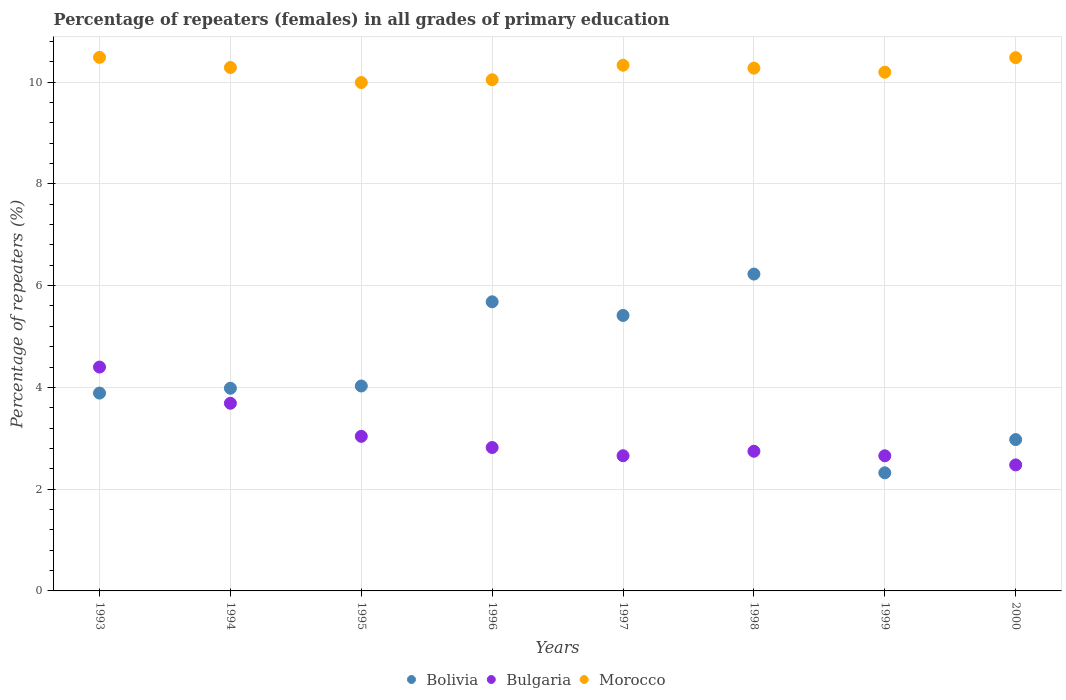How many different coloured dotlines are there?
Make the answer very short. 3. Is the number of dotlines equal to the number of legend labels?
Your answer should be compact. Yes. What is the percentage of repeaters (females) in Bolivia in 1999?
Make the answer very short. 2.32. Across all years, what is the maximum percentage of repeaters (females) in Morocco?
Offer a terse response. 10.49. Across all years, what is the minimum percentage of repeaters (females) in Bolivia?
Your response must be concise. 2.32. What is the total percentage of repeaters (females) in Bulgaria in the graph?
Your answer should be compact. 24.48. What is the difference between the percentage of repeaters (females) in Morocco in 1994 and that in 1997?
Your answer should be very brief. -0.04. What is the difference between the percentage of repeaters (females) in Bulgaria in 1993 and the percentage of repeaters (females) in Morocco in 1999?
Offer a terse response. -5.8. What is the average percentage of repeaters (females) in Morocco per year?
Your response must be concise. 10.26. In the year 1997, what is the difference between the percentage of repeaters (females) in Morocco and percentage of repeaters (females) in Bulgaria?
Your answer should be very brief. 7.67. What is the ratio of the percentage of repeaters (females) in Morocco in 1996 to that in 1998?
Your answer should be very brief. 0.98. Is the percentage of repeaters (females) in Bolivia in 1995 less than that in 1999?
Keep it short and to the point. No. Is the difference between the percentage of repeaters (females) in Morocco in 1994 and 1998 greater than the difference between the percentage of repeaters (females) in Bulgaria in 1994 and 1998?
Make the answer very short. No. What is the difference between the highest and the second highest percentage of repeaters (females) in Morocco?
Keep it short and to the point. 0.01. What is the difference between the highest and the lowest percentage of repeaters (females) in Bulgaria?
Your answer should be compact. 1.92. Is the sum of the percentage of repeaters (females) in Bolivia in 1996 and 1997 greater than the maximum percentage of repeaters (females) in Bulgaria across all years?
Provide a short and direct response. Yes. Is it the case that in every year, the sum of the percentage of repeaters (females) in Morocco and percentage of repeaters (females) in Bolivia  is greater than the percentage of repeaters (females) in Bulgaria?
Ensure brevity in your answer.  Yes. Does the percentage of repeaters (females) in Bolivia monotonically increase over the years?
Give a very brief answer. No. Is the percentage of repeaters (females) in Bulgaria strictly greater than the percentage of repeaters (females) in Bolivia over the years?
Provide a succinct answer. No. How many dotlines are there?
Keep it short and to the point. 3. How many years are there in the graph?
Offer a terse response. 8. Are the values on the major ticks of Y-axis written in scientific E-notation?
Ensure brevity in your answer.  No. Does the graph contain any zero values?
Provide a short and direct response. No. How many legend labels are there?
Make the answer very short. 3. How are the legend labels stacked?
Offer a very short reply. Horizontal. What is the title of the graph?
Your answer should be very brief. Percentage of repeaters (females) in all grades of primary education. Does "Central African Republic" appear as one of the legend labels in the graph?
Offer a terse response. No. What is the label or title of the Y-axis?
Make the answer very short. Percentage of repeaters (%). What is the Percentage of repeaters (%) in Bolivia in 1993?
Your response must be concise. 3.89. What is the Percentage of repeaters (%) of Bulgaria in 1993?
Provide a short and direct response. 4.4. What is the Percentage of repeaters (%) in Morocco in 1993?
Provide a short and direct response. 10.49. What is the Percentage of repeaters (%) of Bolivia in 1994?
Provide a succinct answer. 3.98. What is the Percentage of repeaters (%) in Bulgaria in 1994?
Give a very brief answer. 3.69. What is the Percentage of repeaters (%) in Morocco in 1994?
Offer a very short reply. 10.29. What is the Percentage of repeaters (%) of Bolivia in 1995?
Your response must be concise. 4.03. What is the Percentage of repeaters (%) in Bulgaria in 1995?
Your answer should be very brief. 3.04. What is the Percentage of repeaters (%) of Morocco in 1995?
Your answer should be very brief. 9.99. What is the Percentage of repeaters (%) of Bolivia in 1996?
Provide a short and direct response. 5.68. What is the Percentage of repeaters (%) of Bulgaria in 1996?
Offer a terse response. 2.82. What is the Percentage of repeaters (%) in Morocco in 1996?
Provide a succinct answer. 10.05. What is the Percentage of repeaters (%) in Bolivia in 1997?
Ensure brevity in your answer.  5.41. What is the Percentage of repeaters (%) in Bulgaria in 1997?
Your answer should be compact. 2.66. What is the Percentage of repeaters (%) of Morocco in 1997?
Give a very brief answer. 10.33. What is the Percentage of repeaters (%) of Bolivia in 1998?
Make the answer very short. 6.23. What is the Percentage of repeaters (%) of Bulgaria in 1998?
Your answer should be compact. 2.74. What is the Percentage of repeaters (%) of Morocco in 1998?
Your answer should be very brief. 10.27. What is the Percentage of repeaters (%) in Bolivia in 1999?
Keep it short and to the point. 2.32. What is the Percentage of repeaters (%) in Bulgaria in 1999?
Ensure brevity in your answer.  2.66. What is the Percentage of repeaters (%) in Morocco in 1999?
Keep it short and to the point. 10.2. What is the Percentage of repeaters (%) of Bolivia in 2000?
Your answer should be compact. 2.97. What is the Percentage of repeaters (%) of Bulgaria in 2000?
Give a very brief answer. 2.48. What is the Percentage of repeaters (%) in Morocco in 2000?
Offer a very short reply. 10.48. Across all years, what is the maximum Percentage of repeaters (%) of Bolivia?
Your answer should be compact. 6.23. Across all years, what is the maximum Percentage of repeaters (%) of Bulgaria?
Offer a very short reply. 4.4. Across all years, what is the maximum Percentage of repeaters (%) of Morocco?
Offer a very short reply. 10.49. Across all years, what is the minimum Percentage of repeaters (%) of Bolivia?
Give a very brief answer. 2.32. Across all years, what is the minimum Percentage of repeaters (%) of Bulgaria?
Make the answer very short. 2.48. Across all years, what is the minimum Percentage of repeaters (%) in Morocco?
Ensure brevity in your answer.  9.99. What is the total Percentage of repeaters (%) in Bolivia in the graph?
Offer a terse response. 34.52. What is the total Percentage of repeaters (%) in Bulgaria in the graph?
Your answer should be compact. 24.48. What is the total Percentage of repeaters (%) of Morocco in the graph?
Your answer should be compact. 82.1. What is the difference between the Percentage of repeaters (%) of Bolivia in 1993 and that in 1994?
Give a very brief answer. -0.1. What is the difference between the Percentage of repeaters (%) of Bulgaria in 1993 and that in 1994?
Provide a short and direct response. 0.71. What is the difference between the Percentage of repeaters (%) in Morocco in 1993 and that in 1994?
Offer a terse response. 0.2. What is the difference between the Percentage of repeaters (%) of Bolivia in 1993 and that in 1995?
Offer a terse response. -0.14. What is the difference between the Percentage of repeaters (%) of Bulgaria in 1993 and that in 1995?
Provide a succinct answer. 1.36. What is the difference between the Percentage of repeaters (%) of Morocco in 1993 and that in 1995?
Provide a short and direct response. 0.49. What is the difference between the Percentage of repeaters (%) in Bolivia in 1993 and that in 1996?
Provide a succinct answer. -1.79. What is the difference between the Percentage of repeaters (%) in Bulgaria in 1993 and that in 1996?
Make the answer very short. 1.58. What is the difference between the Percentage of repeaters (%) in Morocco in 1993 and that in 1996?
Offer a very short reply. 0.44. What is the difference between the Percentage of repeaters (%) of Bolivia in 1993 and that in 1997?
Make the answer very short. -1.53. What is the difference between the Percentage of repeaters (%) in Bulgaria in 1993 and that in 1997?
Provide a short and direct response. 1.74. What is the difference between the Percentage of repeaters (%) in Morocco in 1993 and that in 1997?
Provide a short and direct response. 0.15. What is the difference between the Percentage of repeaters (%) of Bolivia in 1993 and that in 1998?
Provide a short and direct response. -2.34. What is the difference between the Percentage of repeaters (%) of Bulgaria in 1993 and that in 1998?
Provide a short and direct response. 1.65. What is the difference between the Percentage of repeaters (%) of Morocco in 1993 and that in 1998?
Your answer should be compact. 0.21. What is the difference between the Percentage of repeaters (%) of Bolivia in 1993 and that in 1999?
Provide a short and direct response. 1.57. What is the difference between the Percentage of repeaters (%) in Bulgaria in 1993 and that in 1999?
Keep it short and to the point. 1.74. What is the difference between the Percentage of repeaters (%) in Morocco in 1993 and that in 1999?
Your answer should be compact. 0.29. What is the difference between the Percentage of repeaters (%) of Bolivia in 1993 and that in 2000?
Provide a succinct answer. 0.91. What is the difference between the Percentage of repeaters (%) of Bulgaria in 1993 and that in 2000?
Provide a succinct answer. 1.92. What is the difference between the Percentage of repeaters (%) in Morocco in 1993 and that in 2000?
Make the answer very short. 0.01. What is the difference between the Percentage of repeaters (%) in Bolivia in 1994 and that in 1995?
Your response must be concise. -0.04. What is the difference between the Percentage of repeaters (%) in Bulgaria in 1994 and that in 1995?
Your answer should be compact. 0.65. What is the difference between the Percentage of repeaters (%) of Morocco in 1994 and that in 1995?
Your answer should be very brief. 0.3. What is the difference between the Percentage of repeaters (%) of Bolivia in 1994 and that in 1996?
Provide a short and direct response. -1.7. What is the difference between the Percentage of repeaters (%) of Bulgaria in 1994 and that in 1996?
Your answer should be very brief. 0.87. What is the difference between the Percentage of repeaters (%) in Morocco in 1994 and that in 1996?
Ensure brevity in your answer.  0.24. What is the difference between the Percentage of repeaters (%) of Bolivia in 1994 and that in 1997?
Offer a very short reply. -1.43. What is the difference between the Percentage of repeaters (%) in Bulgaria in 1994 and that in 1997?
Offer a terse response. 1.03. What is the difference between the Percentage of repeaters (%) in Morocco in 1994 and that in 1997?
Ensure brevity in your answer.  -0.04. What is the difference between the Percentage of repeaters (%) of Bolivia in 1994 and that in 1998?
Your response must be concise. -2.24. What is the difference between the Percentage of repeaters (%) in Bulgaria in 1994 and that in 1998?
Provide a succinct answer. 0.94. What is the difference between the Percentage of repeaters (%) in Morocco in 1994 and that in 1998?
Provide a succinct answer. 0.01. What is the difference between the Percentage of repeaters (%) of Bolivia in 1994 and that in 1999?
Offer a very short reply. 1.66. What is the difference between the Percentage of repeaters (%) of Bulgaria in 1994 and that in 1999?
Make the answer very short. 1.03. What is the difference between the Percentage of repeaters (%) of Morocco in 1994 and that in 1999?
Your response must be concise. 0.09. What is the difference between the Percentage of repeaters (%) in Bolivia in 1994 and that in 2000?
Provide a short and direct response. 1.01. What is the difference between the Percentage of repeaters (%) in Bulgaria in 1994 and that in 2000?
Your response must be concise. 1.21. What is the difference between the Percentage of repeaters (%) in Morocco in 1994 and that in 2000?
Offer a terse response. -0.19. What is the difference between the Percentage of repeaters (%) of Bolivia in 1995 and that in 1996?
Your answer should be very brief. -1.65. What is the difference between the Percentage of repeaters (%) in Bulgaria in 1995 and that in 1996?
Offer a terse response. 0.22. What is the difference between the Percentage of repeaters (%) of Morocco in 1995 and that in 1996?
Offer a very short reply. -0.05. What is the difference between the Percentage of repeaters (%) of Bolivia in 1995 and that in 1997?
Ensure brevity in your answer.  -1.39. What is the difference between the Percentage of repeaters (%) in Bulgaria in 1995 and that in 1997?
Give a very brief answer. 0.38. What is the difference between the Percentage of repeaters (%) of Morocco in 1995 and that in 1997?
Provide a succinct answer. -0.34. What is the difference between the Percentage of repeaters (%) in Bolivia in 1995 and that in 1998?
Ensure brevity in your answer.  -2.2. What is the difference between the Percentage of repeaters (%) in Bulgaria in 1995 and that in 1998?
Offer a very short reply. 0.29. What is the difference between the Percentage of repeaters (%) of Morocco in 1995 and that in 1998?
Provide a short and direct response. -0.28. What is the difference between the Percentage of repeaters (%) of Bolivia in 1995 and that in 1999?
Offer a very short reply. 1.71. What is the difference between the Percentage of repeaters (%) of Bulgaria in 1995 and that in 1999?
Keep it short and to the point. 0.38. What is the difference between the Percentage of repeaters (%) in Morocco in 1995 and that in 1999?
Your answer should be very brief. -0.2. What is the difference between the Percentage of repeaters (%) in Bolivia in 1995 and that in 2000?
Ensure brevity in your answer.  1.05. What is the difference between the Percentage of repeaters (%) of Bulgaria in 1995 and that in 2000?
Keep it short and to the point. 0.56. What is the difference between the Percentage of repeaters (%) of Morocco in 1995 and that in 2000?
Make the answer very short. -0.49. What is the difference between the Percentage of repeaters (%) in Bolivia in 1996 and that in 1997?
Your answer should be very brief. 0.27. What is the difference between the Percentage of repeaters (%) of Bulgaria in 1996 and that in 1997?
Provide a succinct answer. 0.16. What is the difference between the Percentage of repeaters (%) in Morocco in 1996 and that in 1997?
Give a very brief answer. -0.29. What is the difference between the Percentage of repeaters (%) in Bolivia in 1996 and that in 1998?
Ensure brevity in your answer.  -0.55. What is the difference between the Percentage of repeaters (%) of Bulgaria in 1996 and that in 1998?
Keep it short and to the point. 0.07. What is the difference between the Percentage of repeaters (%) in Morocco in 1996 and that in 1998?
Keep it short and to the point. -0.23. What is the difference between the Percentage of repeaters (%) of Bolivia in 1996 and that in 1999?
Give a very brief answer. 3.36. What is the difference between the Percentage of repeaters (%) of Bulgaria in 1996 and that in 1999?
Your answer should be compact. 0.16. What is the difference between the Percentage of repeaters (%) in Morocco in 1996 and that in 1999?
Provide a succinct answer. -0.15. What is the difference between the Percentage of repeaters (%) of Bolivia in 1996 and that in 2000?
Make the answer very short. 2.71. What is the difference between the Percentage of repeaters (%) in Bulgaria in 1996 and that in 2000?
Keep it short and to the point. 0.34. What is the difference between the Percentage of repeaters (%) in Morocco in 1996 and that in 2000?
Provide a short and direct response. -0.43. What is the difference between the Percentage of repeaters (%) of Bolivia in 1997 and that in 1998?
Keep it short and to the point. -0.81. What is the difference between the Percentage of repeaters (%) of Bulgaria in 1997 and that in 1998?
Ensure brevity in your answer.  -0.09. What is the difference between the Percentage of repeaters (%) in Morocco in 1997 and that in 1998?
Your response must be concise. 0.06. What is the difference between the Percentage of repeaters (%) in Bolivia in 1997 and that in 1999?
Your answer should be compact. 3.09. What is the difference between the Percentage of repeaters (%) in Bulgaria in 1997 and that in 1999?
Give a very brief answer. 0. What is the difference between the Percentage of repeaters (%) in Morocco in 1997 and that in 1999?
Your answer should be compact. 0.14. What is the difference between the Percentage of repeaters (%) in Bolivia in 1997 and that in 2000?
Make the answer very short. 2.44. What is the difference between the Percentage of repeaters (%) in Bulgaria in 1997 and that in 2000?
Provide a succinct answer. 0.18. What is the difference between the Percentage of repeaters (%) in Morocco in 1997 and that in 2000?
Make the answer very short. -0.15. What is the difference between the Percentage of repeaters (%) of Bolivia in 1998 and that in 1999?
Provide a short and direct response. 3.91. What is the difference between the Percentage of repeaters (%) in Bulgaria in 1998 and that in 1999?
Your answer should be compact. 0.09. What is the difference between the Percentage of repeaters (%) in Morocco in 1998 and that in 1999?
Your answer should be very brief. 0.08. What is the difference between the Percentage of repeaters (%) of Bolivia in 1998 and that in 2000?
Give a very brief answer. 3.25. What is the difference between the Percentage of repeaters (%) in Bulgaria in 1998 and that in 2000?
Keep it short and to the point. 0.27. What is the difference between the Percentage of repeaters (%) in Morocco in 1998 and that in 2000?
Make the answer very short. -0.21. What is the difference between the Percentage of repeaters (%) in Bolivia in 1999 and that in 2000?
Your answer should be compact. -0.65. What is the difference between the Percentage of repeaters (%) in Bulgaria in 1999 and that in 2000?
Your answer should be very brief. 0.18. What is the difference between the Percentage of repeaters (%) in Morocco in 1999 and that in 2000?
Ensure brevity in your answer.  -0.29. What is the difference between the Percentage of repeaters (%) in Bolivia in 1993 and the Percentage of repeaters (%) in Bulgaria in 1994?
Offer a terse response. 0.2. What is the difference between the Percentage of repeaters (%) in Bolivia in 1993 and the Percentage of repeaters (%) in Morocco in 1994?
Offer a terse response. -6.4. What is the difference between the Percentage of repeaters (%) of Bulgaria in 1993 and the Percentage of repeaters (%) of Morocco in 1994?
Give a very brief answer. -5.89. What is the difference between the Percentage of repeaters (%) of Bolivia in 1993 and the Percentage of repeaters (%) of Bulgaria in 1995?
Keep it short and to the point. 0.85. What is the difference between the Percentage of repeaters (%) in Bolivia in 1993 and the Percentage of repeaters (%) in Morocco in 1995?
Your response must be concise. -6.1. What is the difference between the Percentage of repeaters (%) of Bulgaria in 1993 and the Percentage of repeaters (%) of Morocco in 1995?
Keep it short and to the point. -5.59. What is the difference between the Percentage of repeaters (%) in Bolivia in 1993 and the Percentage of repeaters (%) in Bulgaria in 1996?
Your answer should be compact. 1.07. What is the difference between the Percentage of repeaters (%) of Bolivia in 1993 and the Percentage of repeaters (%) of Morocco in 1996?
Make the answer very short. -6.16. What is the difference between the Percentage of repeaters (%) in Bulgaria in 1993 and the Percentage of repeaters (%) in Morocco in 1996?
Provide a succinct answer. -5.65. What is the difference between the Percentage of repeaters (%) in Bolivia in 1993 and the Percentage of repeaters (%) in Bulgaria in 1997?
Ensure brevity in your answer.  1.23. What is the difference between the Percentage of repeaters (%) in Bolivia in 1993 and the Percentage of repeaters (%) in Morocco in 1997?
Provide a succinct answer. -6.44. What is the difference between the Percentage of repeaters (%) of Bulgaria in 1993 and the Percentage of repeaters (%) of Morocco in 1997?
Provide a short and direct response. -5.93. What is the difference between the Percentage of repeaters (%) in Bolivia in 1993 and the Percentage of repeaters (%) in Bulgaria in 1998?
Your answer should be very brief. 1.14. What is the difference between the Percentage of repeaters (%) in Bolivia in 1993 and the Percentage of repeaters (%) in Morocco in 1998?
Provide a succinct answer. -6.39. What is the difference between the Percentage of repeaters (%) of Bulgaria in 1993 and the Percentage of repeaters (%) of Morocco in 1998?
Your answer should be compact. -5.88. What is the difference between the Percentage of repeaters (%) in Bolivia in 1993 and the Percentage of repeaters (%) in Bulgaria in 1999?
Offer a very short reply. 1.23. What is the difference between the Percentage of repeaters (%) in Bolivia in 1993 and the Percentage of repeaters (%) in Morocco in 1999?
Your answer should be very brief. -6.31. What is the difference between the Percentage of repeaters (%) in Bulgaria in 1993 and the Percentage of repeaters (%) in Morocco in 1999?
Your response must be concise. -5.8. What is the difference between the Percentage of repeaters (%) in Bolivia in 1993 and the Percentage of repeaters (%) in Bulgaria in 2000?
Provide a short and direct response. 1.41. What is the difference between the Percentage of repeaters (%) in Bolivia in 1993 and the Percentage of repeaters (%) in Morocco in 2000?
Ensure brevity in your answer.  -6.59. What is the difference between the Percentage of repeaters (%) in Bulgaria in 1993 and the Percentage of repeaters (%) in Morocco in 2000?
Offer a very short reply. -6.08. What is the difference between the Percentage of repeaters (%) in Bolivia in 1994 and the Percentage of repeaters (%) in Bulgaria in 1995?
Provide a succinct answer. 0.94. What is the difference between the Percentage of repeaters (%) in Bolivia in 1994 and the Percentage of repeaters (%) in Morocco in 1995?
Make the answer very short. -6.01. What is the difference between the Percentage of repeaters (%) of Bulgaria in 1994 and the Percentage of repeaters (%) of Morocco in 1995?
Give a very brief answer. -6.3. What is the difference between the Percentage of repeaters (%) in Bolivia in 1994 and the Percentage of repeaters (%) in Bulgaria in 1996?
Keep it short and to the point. 1.16. What is the difference between the Percentage of repeaters (%) of Bolivia in 1994 and the Percentage of repeaters (%) of Morocco in 1996?
Offer a terse response. -6.06. What is the difference between the Percentage of repeaters (%) in Bulgaria in 1994 and the Percentage of repeaters (%) in Morocco in 1996?
Give a very brief answer. -6.36. What is the difference between the Percentage of repeaters (%) of Bolivia in 1994 and the Percentage of repeaters (%) of Bulgaria in 1997?
Give a very brief answer. 1.33. What is the difference between the Percentage of repeaters (%) in Bolivia in 1994 and the Percentage of repeaters (%) in Morocco in 1997?
Provide a short and direct response. -6.35. What is the difference between the Percentage of repeaters (%) of Bulgaria in 1994 and the Percentage of repeaters (%) of Morocco in 1997?
Keep it short and to the point. -6.64. What is the difference between the Percentage of repeaters (%) in Bolivia in 1994 and the Percentage of repeaters (%) in Bulgaria in 1998?
Give a very brief answer. 1.24. What is the difference between the Percentage of repeaters (%) of Bolivia in 1994 and the Percentage of repeaters (%) of Morocco in 1998?
Offer a very short reply. -6.29. What is the difference between the Percentage of repeaters (%) of Bulgaria in 1994 and the Percentage of repeaters (%) of Morocco in 1998?
Your response must be concise. -6.59. What is the difference between the Percentage of repeaters (%) of Bolivia in 1994 and the Percentage of repeaters (%) of Bulgaria in 1999?
Provide a succinct answer. 1.33. What is the difference between the Percentage of repeaters (%) of Bolivia in 1994 and the Percentage of repeaters (%) of Morocco in 1999?
Offer a terse response. -6.21. What is the difference between the Percentage of repeaters (%) of Bulgaria in 1994 and the Percentage of repeaters (%) of Morocco in 1999?
Keep it short and to the point. -6.51. What is the difference between the Percentage of repeaters (%) in Bolivia in 1994 and the Percentage of repeaters (%) in Bulgaria in 2000?
Give a very brief answer. 1.51. What is the difference between the Percentage of repeaters (%) in Bolivia in 1994 and the Percentage of repeaters (%) in Morocco in 2000?
Offer a very short reply. -6.5. What is the difference between the Percentage of repeaters (%) in Bulgaria in 1994 and the Percentage of repeaters (%) in Morocco in 2000?
Make the answer very short. -6.79. What is the difference between the Percentage of repeaters (%) of Bolivia in 1995 and the Percentage of repeaters (%) of Bulgaria in 1996?
Offer a terse response. 1.21. What is the difference between the Percentage of repeaters (%) of Bolivia in 1995 and the Percentage of repeaters (%) of Morocco in 1996?
Keep it short and to the point. -6.02. What is the difference between the Percentage of repeaters (%) of Bulgaria in 1995 and the Percentage of repeaters (%) of Morocco in 1996?
Make the answer very short. -7.01. What is the difference between the Percentage of repeaters (%) of Bolivia in 1995 and the Percentage of repeaters (%) of Bulgaria in 1997?
Make the answer very short. 1.37. What is the difference between the Percentage of repeaters (%) of Bolivia in 1995 and the Percentage of repeaters (%) of Morocco in 1997?
Your answer should be compact. -6.3. What is the difference between the Percentage of repeaters (%) of Bulgaria in 1995 and the Percentage of repeaters (%) of Morocco in 1997?
Offer a terse response. -7.29. What is the difference between the Percentage of repeaters (%) of Bolivia in 1995 and the Percentage of repeaters (%) of Bulgaria in 1998?
Ensure brevity in your answer.  1.28. What is the difference between the Percentage of repeaters (%) of Bolivia in 1995 and the Percentage of repeaters (%) of Morocco in 1998?
Keep it short and to the point. -6.25. What is the difference between the Percentage of repeaters (%) in Bulgaria in 1995 and the Percentage of repeaters (%) in Morocco in 1998?
Provide a short and direct response. -7.24. What is the difference between the Percentage of repeaters (%) in Bolivia in 1995 and the Percentage of repeaters (%) in Bulgaria in 1999?
Make the answer very short. 1.37. What is the difference between the Percentage of repeaters (%) of Bolivia in 1995 and the Percentage of repeaters (%) of Morocco in 1999?
Offer a terse response. -6.17. What is the difference between the Percentage of repeaters (%) in Bulgaria in 1995 and the Percentage of repeaters (%) in Morocco in 1999?
Give a very brief answer. -7.16. What is the difference between the Percentage of repeaters (%) of Bolivia in 1995 and the Percentage of repeaters (%) of Bulgaria in 2000?
Provide a succinct answer. 1.55. What is the difference between the Percentage of repeaters (%) of Bolivia in 1995 and the Percentage of repeaters (%) of Morocco in 2000?
Give a very brief answer. -6.45. What is the difference between the Percentage of repeaters (%) in Bulgaria in 1995 and the Percentage of repeaters (%) in Morocco in 2000?
Provide a succinct answer. -7.44. What is the difference between the Percentage of repeaters (%) of Bolivia in 1996 and the Percentage of repeaters (%) of Bulgaria in 1997?
Make the answer very short. 3.03. What is the difference between the Percentage of repeaters (%) of Bolivia in 1996 and the Percentage of repeaters (%) of Morocco in 1997?
Provide a succinct answer. -4.65. What is the difference between the Percentage of repeaters (%) of Bulgaria in 1996 and the Percentage of repeaters (%) of Morocco in 1997?
Your answer should be very brief. -7.51. What is the difference between the Percentage of repeaters (%) of Bolivia in 1996 and the Percentage of repeaters (%) of Bulgaria in 1998?
Your answer should be compact. 2.94. What is the difference between the Percentage of repeaters (%) in Bolivia in 1996 and the Percentage of repeaters (%) in Morocco in 1998?
Keep it short and to the point. -4.59. What is the difference between the Percentage of repeaters (%) in Bulgaria in 1996 and the Percentage of repeaters (%) in Morocco in 1998?
Provide a succinct answer. -7.46. What is the difference between the Percentage of repeaters (%) in Bolivia in 1996 and the Percentage of repeaters (%) in Bulgaria in 1999?
Offer a very short reply. 3.03. What is the difference between the Percentage of repeaters (%) in Bolivia in 1996 and the Percentage of repeaters (%) in Morocco in 1999?
Provide a succinct answer. -4.51. What is the difference between the Percentage of repeaters (%) in Bulgaria in 1996 and the Percentage of repeaters (%) in Morocco in 1999?
Provide a short and direct response. -7.38. What is the difference between the Percentage of repeaters (%) of Bolivia in 1996 and the Percentage of repeaters (%) of Bulgaria in 2000?
Your answer should be very brief. 3.21. What is the difference between the Percentage of repeaters (%) of Bolivia in 1996 and the Percentage of repeaters (%) of Morocco in 2000?
Offer a very short reply. -4.8. What is the difference between the Percentage of repeaters (%) in Bulgaria in 1996 and the Percentage of repeaters (%) in Morocco in 2000?
Your answer should be compact. -7.66. What is the difference between the Percentage of repeaters (%) of Bolivia in 1997 and the Percentage of repeaters (%) of Bulgaria in 1998?
Provide a short and direct response. 2.67. What is the difference between the Percentage of repeaters (%) of Bolivia in 1997 and the Percentage of repeaters (%) of Morocco in 1998?
Your response must be concise. -4.86. What is the difference between the Percentage of repeaters (%) in Bulgaria in 1997 and the Percentage of repeaters (%) in Morocco in 1998?
Offer a very short reply. -7.62. What is the difference between the Percentage of repeaters (%) in Bolivia in 1997 and the Percentage of repeaters (%) in Bulgaria in 1999?
Offer a terse response. 2.76. What is the difference between the Percentage of repeaters (%) in Bolivia in 1997 and the Percentage of repeaters (%) in Morocco in 1999?
Your answer should be very brief. -4.78. What is the difference between the Percentage of repeaters (%) in Bulgaria in 1997 and the Percentage of repeaters (%) in Morocco in 1999?
Offer a very short reply. -7.54. What is the difference between the Percentage of repeaters (%) of Bolivia in 1997 and the Percentage of repeaters (%) of Bulgaria in 2000?
Your response must be concise. 2.94. What is the difference between the Percentage of repeaters (%) in Bolivia in 1997 and the Percentage of repeaters (%) in Morocco in 2000?
Offer a very short reply. -5.07. What is the difference between the Percentage of repeaters (%) of Bulgaria in 1997 and the Percentage of repeaters (%) of Morocco in 2000?
Keep it short and to the point. -7.82. What is the difference between the Percentage of repeaters (%) in Bolivia in 1998 and the Percentage of repeaters (%) in Bulgaria in 1999?
Offer a very short reply. 3.57. What is the difference between the Percentage of repeaters (%) of Bolivia in 1998 and the Percentage of repeaters (%) of Morocco in 1999?
Your response must be concise. -3.97. What is the difference between the Percentage of repeaters (%) of Bulgaria in 1998 and the Percentage of repeaters (%) of Morocco in 1999?
Provide a short and direct response. -7.45. What is the difference between the Percentage of repeaters (%) of Bolivia in 1998 and the Percentage of repeaters (%) of Bulgaria in 2000?
Your answer should be compact. 3.75. What is the difference between the Percentage of repeaters (%) in Bolivia in 1998 and the Percentage of repeaters (%) in Morocco in 2000?
Ensure brevity in your answer.  -4.25. What is the difference between the Percentage of repeaters (%) of Bulgaria in 1998 and the Percentage of repeaters (%) of Morocco in 2000?
Provide a short and direct response. -7.74. What is the difference between the Percentage of repeaters (%) of Bolivia in 1999 and the Percentage of repeaters (%) of Bulgaria in 2000?
Provide a succinct answer. -0.16. What is the difference between the Percentage of repeaters (%) of Bolivia in 1999 and the Percentage of repeaters (%) of Morocco in 2000?
Provide a succinct answer. -8.16. What is the difference between the Percentage of repeaters (%) in Bulgaria in 1999 and the Percentage of repeaters (%) in Morocco in 2000?
Make the answer very short. -7.83. What is the average Percentage of repeaters (%) in Bolivia per year?
Your response must be concise. 4.31. What is the average Percentage of repeaters (%) of Bulgaria per year?
Your answer should be compact. 3.06. What is the average Percentage of repeaters (%) of Morocco per year?
Give a very brief answer. 10.26. In the year 1993, what is the difference between the Percentage of repeaters (%) of Bolivia and Percentage of repeaters (%) of Bulgaria?
Offer a terse response. -0.51. In the year 1993, what is the difference between the Percentage of repeaters (%) of Bolivia and Percentage of repeaters (%) of Morocco?
Keep it short and to the point. -6.6. In the year 1993, what is the difference between the Percentage of repeaters (%) in Bulgaria and Percentage of repeaters (%) in Morocco?
Make the answer very short. -6.09. In the year 1994, what is the difference between the Percentage of repeaters (%) of Bolivia and Percentage of repeaters (%) of Bulgaria?
Ensure brevity in your answer.  0.3. In the year 1994, what is the difference between the Percentage of repeaters (%) of Bolivia and Percentage of repeaters (%) of Morocco?
Offer a very short reply. -6.3. In the year 1994, what is the difference between the Percentage of repeaters (%) in Bulgaria and Percentage of repeaters (%) in Morocco?
Offer a terse response. -6.6. In the year 1995, what is the difference between the Percentage of repeaters (%) in Bolivia and Percentage of repeaters (%) in Bulgaria?
Your answer should be compact. 0.99. In the year 1995, what is the difference between the Percentage of repeaters (%) in Bolivia and Percentage of repeaters (%) in Morocco?
Offer a terse response. -5.96. In the year 1995, what is the difference between the Percentage of repeaters (%) in Bulgaria and Percentage of repeaters (%) in Morocco?
Make the answer very short. -6.95. In the year 1996, what is the difference between the Percentage of repeaters (%) of Bolivia and Percentage of repeaters (%) of Bulgaria?
Offer a terse response. 2.86. In the year 1996, what is the difference between the Percentage of repeaters (%) in Bolivia and Percentage of repeaters (%) in Morocco?
Your response must be concise. -4.36. In the year 1996, what is the difference between the Percentage of repeaters (%) in Bulgaria and Percentage of repeaters (%) in Morocco?
Offer a terse response. -7.23. In the year 1997, what is the difference between the Percentage of repeaters (%) in Bolivia and Percentage of repeaters (%) in Bulgaria?
Give a very brief answer. 2.76. In the year 1997, what is the difference between the Percentage of repeaters (%) in Bolivia and Percentage of repeaters (%) in Morocco?
Your answer should be compact. -4.92. In the year 1997, what is the difference between the Percentage of repeaters (%) in Bulgaria and Percentage of repeaters (%) in Morocco?
Give a very brief answer. -7.67. In the year 1998, what is the difference between the Percentage of repeaters (%) in Bolivia and Percentage of repeaters (%) in Bulgaria?
Ensure brevity in your answer.  3.48. In the year 1998, what is the difference between the Percentage of repeaters (%) in Bolivia and Percentage of repeaters (%) in Morocco?
Give a very brief answer. -4.05. In the year 1998, what is the difference between the Percentage of repeaters (%) of Bulgaria and Percentage of repeaters (%) of Morocco?
Make the answer very short. -7.53. In the year 1999, what is the difference between the Percentage of repeaters (%) of Bolivia and Percentage of repeaters (%) of Bulgaria?
Your answer should be compact. -0.33. In the year 1999, what is the difference between the Percentage of repeaters (%) in Bolivia and Percentage of repeaters (%) in Morocco?
Offer a terse response. -7.87. In the year 1999, what is the difference between the Percentage of repeaters (%) in Bulgaria and Percentage of repeaters (%) in Morocco?
Offer a very short reply. -7.54. In the year 2000, what is the difference between the Percentage of repeaters (%) in Bolivia and Percentage of repeaters (%) in Bulgaria?
Offer a very short reply. 0.5. In the year 2000, what is the difference between the Percentage of repeaters (%) in Bolivia and Percentage of repeaters (%) in Morocco?
Offer a very short reply. -7.51. In the year 2000, what is the difference between the Percentage of repeaters (%) of Bulgaria and Percentage of repeaters (%) of Morocco?
Your response must be concise. -8. What is the ratio of the Percentage of repeaters (%) in Bolivia in 1993 to that in 1994?
Give a very brief answer. 0.98. What is the ratio of the Percentage of repeaters (%) of Bulgaria in 1993 to that in 1994?
Ensure brevity in your answer.  1.19. What is the ratio of the Percentage of repeaters (%) of Morocco in 1993 to that in 1994?
Make the answer very short. 1.02. What is the ratio of the Percentage of repeaters (%) in Bolivia in 1993 to that in 1995?
Ensure brevity in your answer.  0.97. What is the ratio of the Percentage of repeaters (%) of Bulgaria in 1993 to that in 1995?
Provide a short and direct response. 1.45. What is the ratio of the Percentage of repeaters (%) in Morocco in 1993 to that in 1995?
Keep it short and to the point. 1.05. What is the ratio of the Percentage of repeaters (%) in Bolivia in 1993 to that in 1996?
Make the answer very short. 0.68. What is the ratio of the Percentage of repeaters (%) of Bulgaria in 1993 to that in 1996?
Your response must be concise. 1.56. What is the ratio of the Percentage of repeaters (%) in Morocco in 1993 to that in 1996?
Make the answer very short. 1.04. What is the ratio of the Percentage of repeaters (%) in Bolivia in 1993 to that in 1997?
Give a very brief answer. 0.72. What is the ratio of the Percentage of repeaters (%) in Bulgaria in 1993 to that in 1997?
Provide a succinct answer. 1.66. What is the ratio of the Percentage of repeaters (%) in Bolivia in 1993 to that in 1998?
Offer a terse response. 0.62. What is the ratio of the Percentage of repeaters (%) in Bulgaria in 1993 to that in 1998?
Ensure brevity in your answer.  1.6. What is the ratio of the Percentage of repeaters (%) of Morocco in 1993 to that in 1998?
Your response must be concise. 1.02. What is the ratio of the Percentage of repeaters (%) of Bolivia in 1993 to that in 1999?
Provide a succinct answer. 1.68. What is the ratio of the Percentage of repeaters (%) in Bulgaria in 1993 to that in 1999?
Your answer should be very brief. 1.66. What is the ratio of the Percentage of repeaters (%) in Morocco in 1993 to that in 1999?
Give a very brief answer. 1.03. What is the ratio of the Percentage of repeaters (%) of Bolivia in 1993 to that in 2000?
Your answer should be very brief. 1.31. What is the ratio of the Percentage of repeaters (%) in Bulgaria in 1993 to that in 2000?
Keep it short and to the point. 1.78. What is the ratio of the Percentage of repeaters (%) of Morocco in 1993 to that in 2000?
Keep it short and to the point. 1. What is the ratio of the Percentage of repeaters (%) in Bulgaria in 1994 to that in 1995?
Offer a very short reply. 1.21. What is the ratio of the Percentage of repeaters (%) in Morocco in 1994 to that in 1995?
Keep it short and to the point. 1.03. What is the ratio of the Percentage of repeaters (%) in Bolivia in 1994 to that in 1996?
Give a very brief answer. 0.7. What is the ratio of the Percentage of repeaters (%) in Bulgaria in 1994 to that in 1996?
Give a very brief answer. 1.31. What is the ratio of the Percentage of repeaters (%) of Morocco in 1994 to that in 1996?
Offer a terse response. 1.02. What is the ratio of the Percentage of repeaters (%) in Bolivia in 1994 to that in 1997?
Offer a terse response. 0.74. What is the ratio of the Percentage of repeaters (%) of Bulgaria in 1994 to that in 1997?
Your answer should be compact. 1.39. What is the ratio of the Percentage of repeaters (%) of Bolivia in 1994 to that in 1998?
Offer a very short reply. 0.64. What is the ratio of the Percentage of repeaters (%) in Bulgaria in 1994 to that in 1998?
Provide a succinct answer. 1.34. What is the ratio of the Percentage of repeaters (%) in Morocco in 1994 to that in 1998?
Keep it short and to the point. 1. What is the ratio of the Percentage of repeaters (%) of Bolivia in 1994 to that in 1999?
Provide a succinct answer. 1.72. What is the ratio of the Percentage of repeaters (%) in Bulgaria in 1994 to that in 1999?
Your answer should be compact. 1.39. What is the ratio of the Percentage of repeaters (%) of Bolivia in 1994 to that in 2000?
Your answer should be very brief. 1.34. What is the ratio of the Percentage of repeaters (%) in Bulgaria in 1994 to that in 2000?
Provide a succinct answer. 1.49. What is the ratio of the Percentage of repeaters (%) in Morocco in 1994 to that in 2000?
Give a very brief answer. 0.98. What is the ratio of the Percentage of repeaters (%) in Bolivia in 1995 to that in 1996?
Offer a very short reply. 0.71. What is the ratio of the Percentage of repeaters (%) in Bulgaria in 1995 to that in 1996?
Your answer should be compact. 1.08. What is the ratio of the Percentage of repeaters (%) in Morocco in 1995 to that in 1996?
Provide a succinct answer. 0.99. What is the ratio of the Percentage of repeaters (%) in Bolivia in 1995 to that in 1997?
Keep it short and to the point. 0.74. What is the ratio of the Percentage of repeaters (%) in Bulgaria in 1995 to that in 1997?
Provide a succinct answer. 1.14. What is the ratio of the Percentage of repeaters (%) in Morocco in 1995 to that in 1997?
Provide a succinct answer. 0.97. What is the ratio of the Percentage of repeaters (%) in Bolivia in 1995 to that in 1998?
Your response must be concise. 0.65. What is the ratio of the Percentage of repeaters (%) in Bulgaria in 1995 to that in 1998?
Give a very brief answer. 1.11. What is the ratio of the Percentage of repeaters (%) in Morocco in 1995 to that in 1998?
Offer a terse response. 0.97. What is the ratio of the Percentage of repeaters (%) of Bolivia in 1995 to that in 1999?
Keep it short and to the point. 1.74. What is the ratio of the Percentage of repeaters (%) of Bulgaria in 1995 to that in 1999?
Give a very brief answer. 1.14. What is the ratio of the Percentage of repeaters (%) of Morocco in 1995 to that in 1999?
Offer a very short reply. 0.98. What is the ratio of the Percentage of repeaters (%) in Bolivia in 1995 to that in 2000?
Offer a terse response. 1.35. What is the ratio of the Percentage of repeaters (%) in Bulgaria in 1995 to that in 2000?
Give a very brief answer. 1.23. What is the ratio of the Percentage of repeaters (%) in Morocco in 1995 to that in 2000?
Your answer should be very brief. 0.95. What is the ratio of the Percentage of repeaters (%) of Bolivia in 1996 to that in 1997?
Provide a succinct answer. 1.05. What is the ratio of the Percentage of repeaters (%) in Bulgaria in 1996 to that in 1997?
Ensure brevity in your answer.  1.06. What is the ratio of the Percentage of repeaters (%) of Morocco in 1996 to that in 1997?
Give a very brief answer. 0.97. What is the ratio of the Percentage of repeaters (%) in Bolivia in 1996 to that in 1998?
Your answer should be very brief. 0.91. What is the ratio of the Percentage of repeaters (%) in Bulgaria in 1996 to that in 1998?
Ensure brevity in your answer.  1.03. What is the ratio of the Percentage of repeaters (%) of Morocco in 1996 to that in 1998?
Provide a short and direct response. 0.98. What is the ratio of the Percentage of repeaters (%) of Bolivia in 1996 to that in 1999?
Your answer should be compact. 2.45. What is the ratio of the Percentage of repeaters (%) of Bulgaria in 1996 to that in 1999?
Your answer should be compact. 1.06. What is the ratio of the Percentage of repeaters (%) of Morocco in 1996 to that in 1999?
Provide a succinct answer. 0.99. What is the ratio of the Percentage of repeaters (%) in Bolivia in 1996 to that in 2000?
Provide a succinct answer. 1.91. What is the ratio of the Percentage of repeaters (%) of Bulgaria in 1996 to that in 2000?
Provide a succinct answer. 1.14. What is the ratio of the Percentage of repeaters (%) in Morocco in 1996 to that in 2000?
Give a very brief answer. 0.96. What is the ratio of the Percentage of repeaters (%) of Bolivia in 1997 to that in 1998?
Keep it short and to the point. 0.87. What is the ratio of the Percentage of repeaters (%) in Morocco in 1997 to that in 1998?
Make the answer very short. 1.01. What is the ratio of the Percentage of repeaters (%) in Bolivia in 1997 to that in 1999?
Your response must be concise. 2.33. What is the ratio of the Percentage of repeaters (%) in Morocco in 1997 to that in 1999?
Ensure brevity in your answer.  1.01. What is the ratio of the Percentage of repeaters (%) of Bolivia in 1997 to that in 2000?
Keep it short and to the point. 1.82. What is the ratio of the Percentage of repeaters (%) of Bulgaria in 1997 to that in 2000?
Ensure brevity in your answer.  1.07. What is the ratio of the Percentage of repeaters (%) in Morocco in 1997 to that in 2000?
Provide a succinct answer. 0.99. What is the ratio of the Percentage of repeaters (%) of Bolivia in 1998 to that in 1999?
Make the answer very short. 2.68. What is the ratio of the Percentage of repeaters (%) of Bulgaria in 1998 to that in 1999?
Your answer should be compact. 1.03. What is the ratio of the Percentage of repeaters (%) in Morocco in 1998 to that in 1999?
Give a very brief answer. 1.01. What is the ratio of the Percentage of repeaters (%) in Bolivia in 1998 to that in 2000?
Provide a short and direct response. 2.09. What is the ratio of the Percentage of repeaters (%) in Bulgaria in 1998 to that in 2000?
Keep it short and to the point. 1.11. What is the ratio of the Percentage of repeaters (%) of Morocco in 1998 to that in 2000?
Make the answer very short. 0.98. What is the ratio of the Percentage of repeaters (%) of Bolivia in 1999 to that in 2000?
Ensure brevity in your answer.  0.78. What is the ratio of the Percentage of repeaters (%) of Bulgaria in 1999 to that in 2000?
Make the answer very short. 1.07. What is the ratio of the Percentage of repeaters (%) of Morocco in 1999 to that in 2000?
Offer a very short reply. 0.97. What is the difference between the highest and the second highest Percentage of repeaters (%) of Bolivia?
Your answer should be very brief. 0.55. What is the difference between the highest and the second highest Percentage of repeaters (%) of Bulgaria?
Make the answer very short. 0.71. What is the difference between the highest and the second highest Percentage of repeaters (%) in Morocco?
Give a very brief answer. 0.01. What is the difference between the highest and the lowest Percentage of repeaters (%) of Bolivia?
Offer a terse response. 3.91. What is the difference between the highest and the lowest Percentage of repeaters (%) in Bulgaria?
Give a very brief answer. 1.92. What is the difference between the highest and the lowest Percentage of repeaters (%) in Morocco?
Keep it short and to the point. 0.49. 